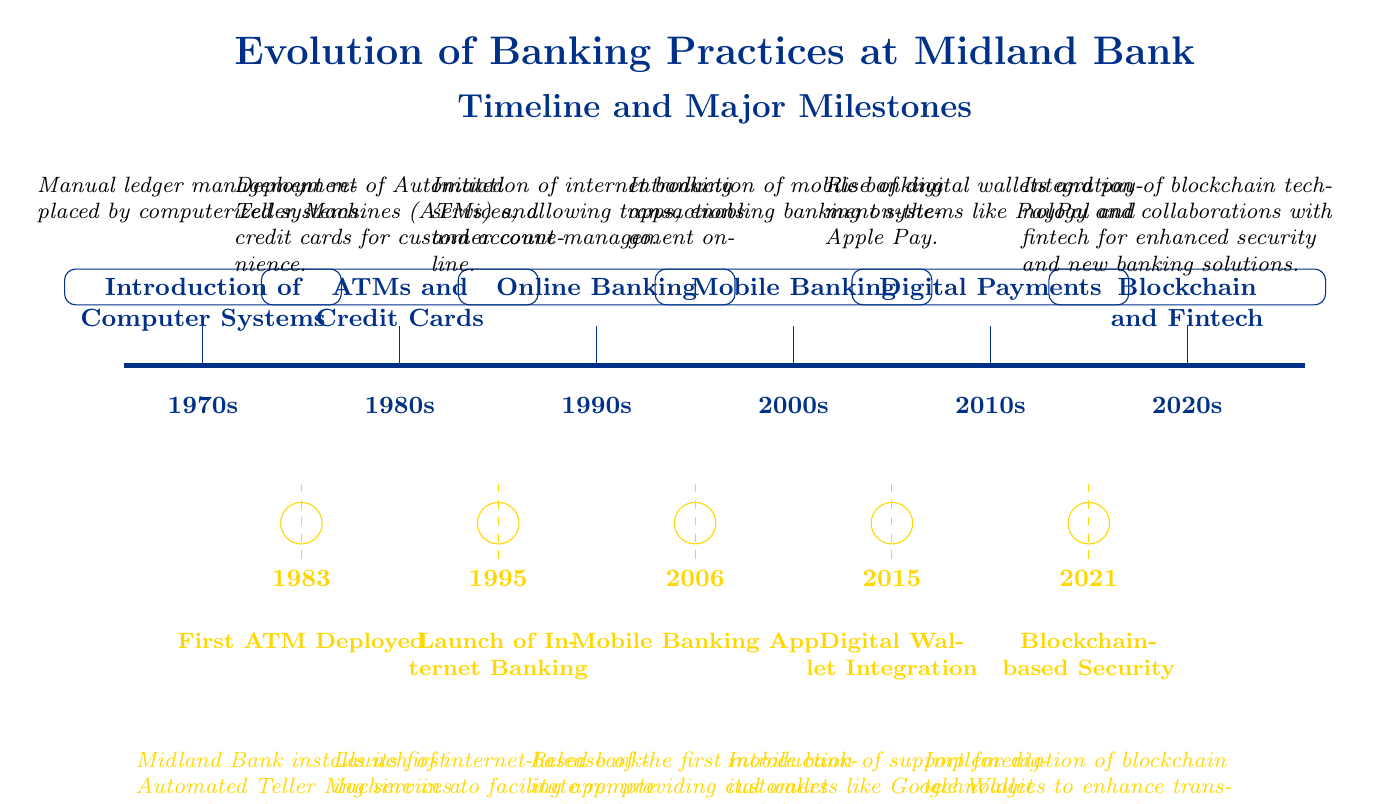What's the first milestone year in the diagram? The first milestone on the timeline is indicated by the marker at 1983, which labels "First ATM Deployed." This is the earliest specific event that is visually represented in the diagram.
Answer: 1983 What was the major event in the 1990s? The major event detailed in the 1990s segment is labeled "Online Banking," and its description states that this initiated internet banking services. The year is indicated as the value 5 on the timeline.
Answer: Online Banking How many milestones are shown in total? The diagram displays a total of five milestones, specifically marked along the lower timeline. Each of these milestones represents a significant advancement in banking practices.
Answer: 5 What technology was integrated in the 2020s? The diagram features a milestone for the 2020s labeled "Blockchain and Fintech," highlighting the integration of blockchain technology into banking practices. This refers to the current technological approach of adopting new security measures and collaborations.
Answer: Blockchain and Fintech Which specific year did Midland Bank launch its internet banking services? The launch of internet banking is prominently noted at the year 1995, which corresponds to the milestone labeled "Launch of Internet Banking." This clearly indicates the timeline of when this advancement occurred.
Answer: 1995 What color represents the timeline in the diagram? The timeline is represented using the color midland blue, as defined at the beginning of the code. This blue color is used consistently to highlight the progression of banking practices over the decades.
Answer: Midland Blue What development occurred in 2006? The diagram denotes that in 2006, the significant milestone was the introduction of a "Mobile Banking App," which illustrates Midland Bank's step toward enhancing mobile banking services for users.
Answer: Mobile Banking App In which decade was the introduction of digital wallets? The integration of digital wallets occurred in the 2010s, specifically represented by the event labeled "Digital Payments," which mirrors the rise in payment systems during that period.
Answer: 2010s What is marked directly below the 1980s event on the timeline? Directly below the 1980s event, which is "ATMs and Credit Cards," is the milestone for "First ATM Deployed" at the year 1983. This milestone is prominently placed to show its relationship to the advancements in ATM technology.
Answer: First ATM Deployed 